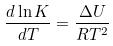Convert formula to latex. <formula><loc_0><loc_0><loc_500><loc_500>\frac { d \ln K } { d T } = \frac { \Delta U } { R T ^ { 2 } }</formula> 